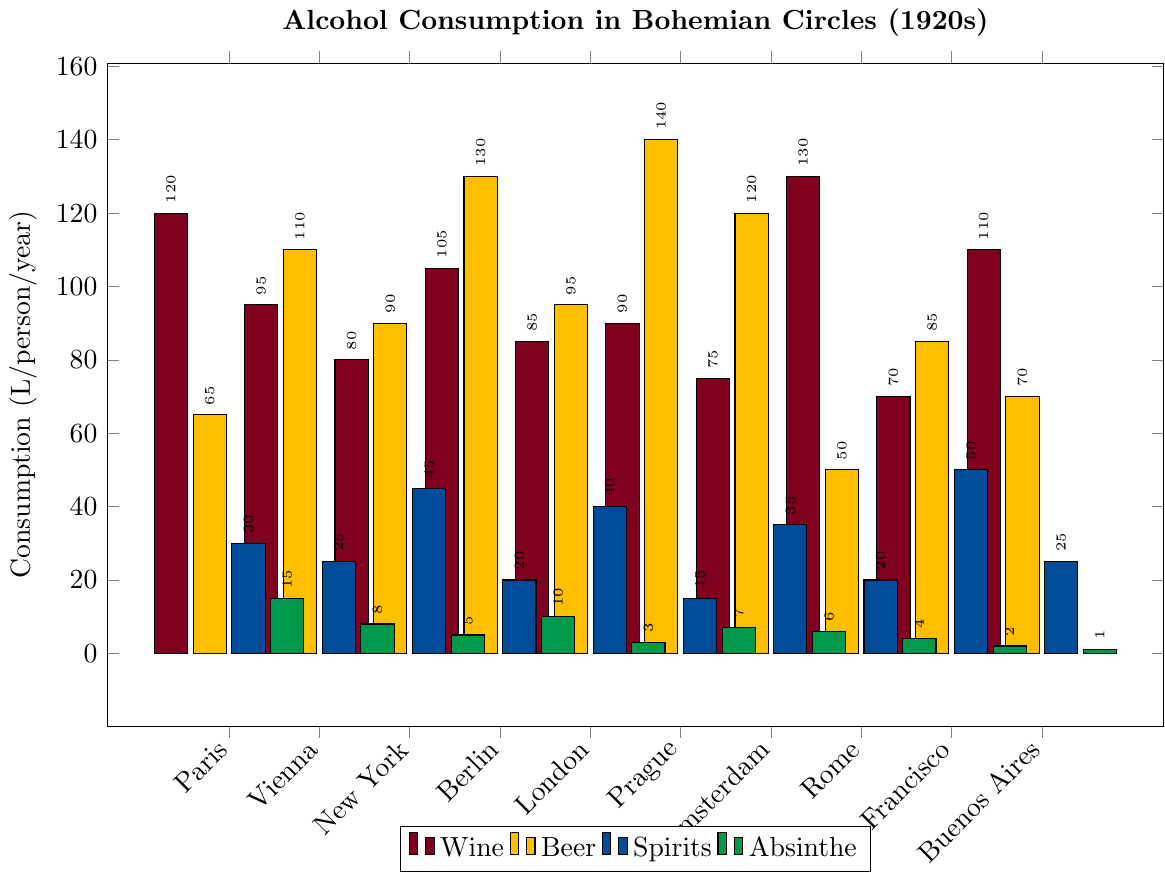What city has the highest consumption of beer? By looking at the height of the bar corresponding to beer (yellow) across all cities, Berlin shows the tallest bar for beer consumption.
Answer: Berlin Which city has the largest overall alcohol consumption (sum of all types)? Calculate the total consumption for each city by adding the values for Wine, Beer, Spirits, and Absinthe and compare these totals. Paris: 230, Vienna: 238, New York: 220, Berlin: 265, London: 223, Prague: 252, Amsterdam: 236, Rome: 204, San Francisco: 207, Buenos Aires: 206. Therefore, Berlin has the highest total consumption.
Answer: Berlin In terms of wine consumption, which two cities lead, and how much more do they consume compared to the city with the third highest wine consumption? The tallest bars for wine (maroon) are in Rome (130) and Paris (120). Buenos Aires is third with (110). Rome consumes 20 liters more than Buenos Aires, while Paris consumes 10 liters more.
Answer: Rome and Paris, respectively; 20 liters and 10 liters more What is the average consumption of absinthe across all cities? Sum the absinthe consumption of all cities (15 + 8 + 5 + 10 + 3 + 7 + 6 + 4 + 2 + 1 = 61). Divide by the number of cities (10), so 61/10 = 6.1 liters/person/year.
Answer: 6.1 Identify the two cities with the lowest consumption of spirits and their combined total consumption. The bars for spirits (blue) are lowest for Prague (15) and Berlin (20). Their combined total is 15 + 20 = 35 liters/person/year.
Answer: Prague and Berlin; 35 Are there any cities where spirits consumption exceeds beer consumption? Check each city’s bars for spirits (blue) and beer (yellow), none of the cities have higher spirits consumption compared to beer.
Answer: No How does Paris rank in terms of overall consumption of spirits compared to the other cities? Rank all cities based on their spirit consumption (ascending order). Paris spirit consumption is 30 which ranks it third place (Vienna, Buenos Aires: 25; Berlin, Rome: 20; London: 40; New York: 45; Amsterdam: 35, San Francisco: 50).
Answer: Third place 